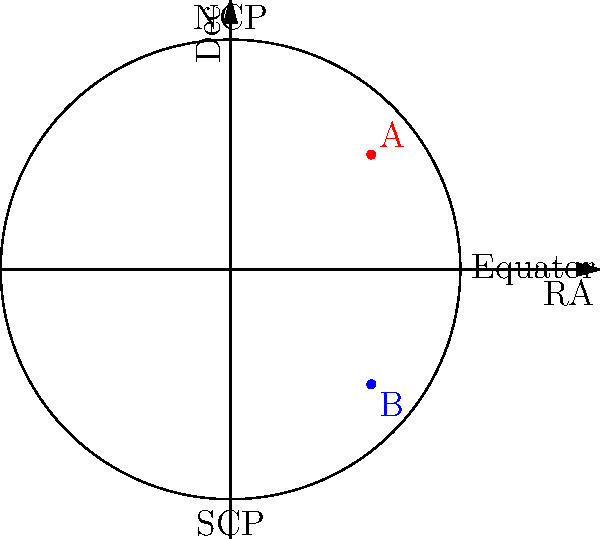In the given 2D star chart projection, two celestial objects A and B are plotted. If object A has a right ascension (RA) of 45° and declination (Dec) of 30°, what are the approximate RA and Dec coordinates of object B? To determine the coordinates of object B, we need to analyze its position relative to object A and the celestial sphere projection:

1. The circle represents the celestial sphere projected onto a 2D plane.
2. The horizontal axis represents right ascension (RA), increasing from left to right.
3. The vertical axis represents declination (Dec), increasing from bottom to top.

Given:
- Object A: RA = 45°, Dec = 30°
- Object A is in the upper-right quadrant of the projection

Analyzing object B's position:
1. RA: B is located further to the right than A, indicating a larger RA value.
   - Estimate: B's RA is about 3 times A's RA, so approximately 135°.

2. Dec: B is below the equator (horizontal line), indicating a negative Dec value.
   - A's Dec is 30° above the equator.
   - B appears to be about the same distance below the equator as A is above it.
   - Estimate: B's Dec is approximately -30°.

Therefore, the approximate coordinates for object B are:
RA ≈ 135° and Dec ≈ -30°
Answer: RA ≈ 135°, Dec ≈ -30° 